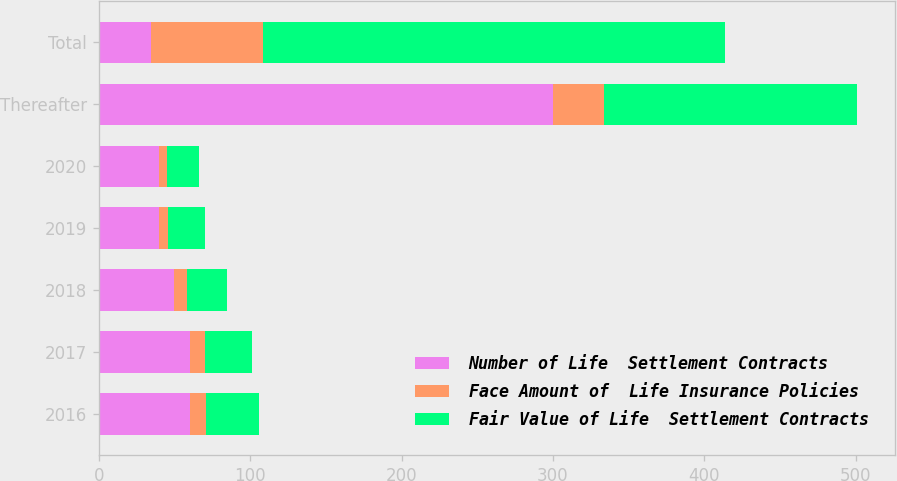<chart> <loc_0><loc_0><loc_500><loc_500><stacked_bar_chart><ecel><fcel>2016<fcel>2017<fcel>2018<fcel>2019<fcel>2020<fcel>Thereafter<fcel>Total<nl><fcel>Number of Life  Settlement Contracts<fcel>60<fcel>60<fcel>50<fcel>40<fcel>40<fcel>300<fcel>34.5<nl><fcel>Face Amount of  Life Insurance Policies<fcel>11<fcel>10<fcel>8<fcel>6<fcel>5<fcel>34<fcel>74<nl><fcel>Fair Value of Life  Settlement Contracts<fcel>35<fcel>31<fcel>27<fcel>24<fcel>21<fcel>167<fcel>305<nl></chart> 